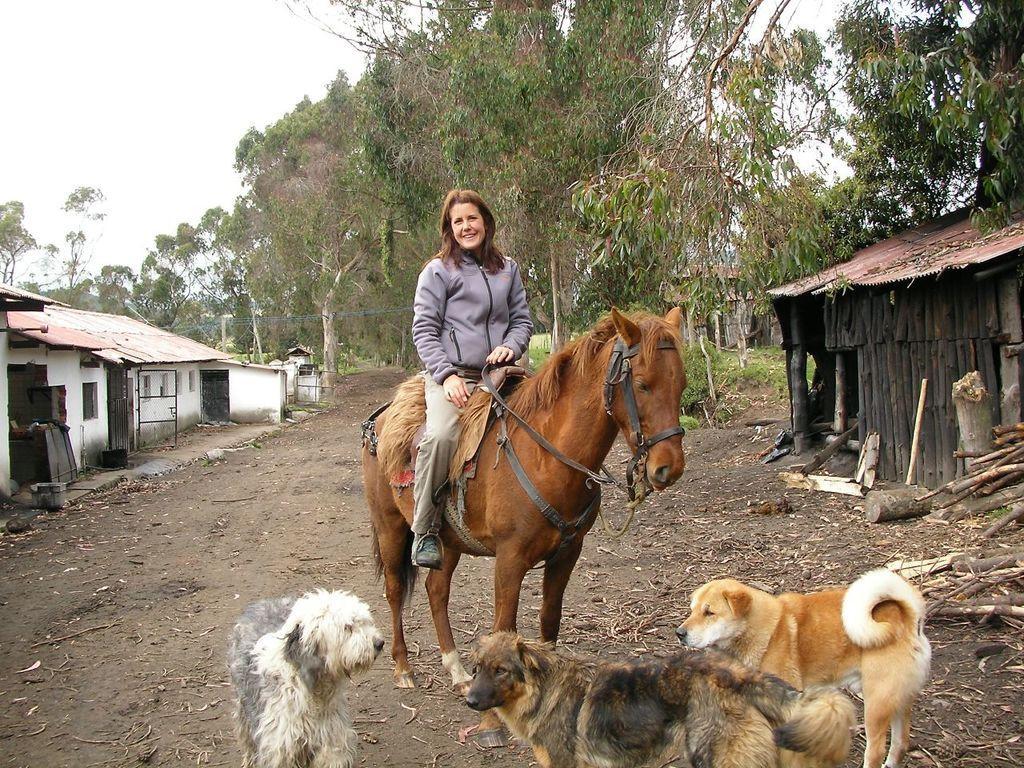Can you describe this image briefly? In this picture we can see a woman wearing a grey jacket is sitting on the brown horse. In the front bottom side there are three dog in the ground. On the left side there is a white house with roofing shed. In the background we can see some trees. 